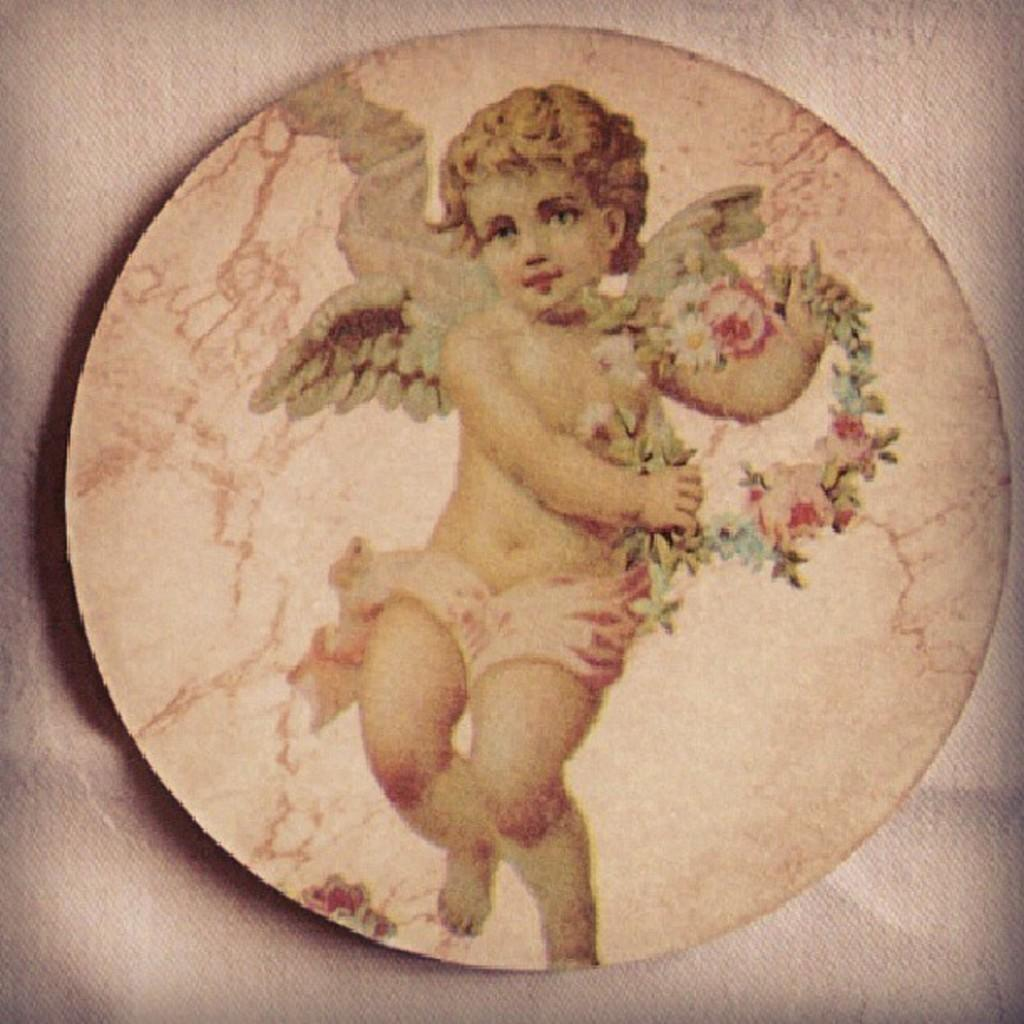What is the main subject of the image? There is a depiction of a boy in the center of the image. How does the acoustics of the hill affect the boy's voice in the image? There is no hill or mention of acoustics in the image; it only depicts a boy. 